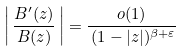<formula> <loc_0><loc_0><loc_500><loc_500>\left | \, \frac { B ^ { \prime } ( z ) } { B ( z ) } \, \right | = \frac { o ( 1 ) } { \, ( 1 - | z | ) ^ { \beta + \varepsilon } }</formula> 